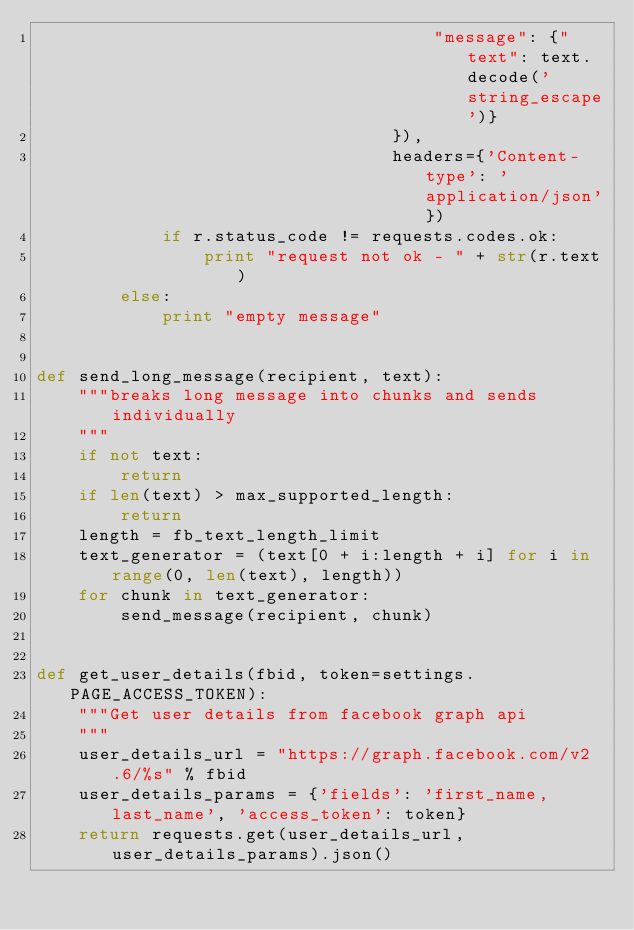<code> <loc_0><loc_0><loc_500><loc_500><_Python_>                                      "message": {"text": text.decode('string_escape')}
                                  }),
                                  headers={'Content-type': 'application/json'})
            if r.status_code != requests.codes.ok:
                print "request not ok - " + str(r.text)
        else:
            print "empty message"


def send_long_message(recipient, text):
    """breaks long message into chunks and sends individually
    """
    if not text:
        return
    if len(text) > max_supported_length:
        return
    length = fb_text_length_limit
    text_generator = (text[0 + i:length + i] for i in range(0, len(text), length))
    for chunk in text_generator:
        send_message(recipient, chunk)


def get_user_details(fbid, token=settings.PAGE_ACCESS_TOKEN):
    """Get user details from facebook graph api
    """
    user_details_url = "https://graph.facebook.com/v2.6/%s" % fbid
    user_details_params = {'fields': 'first_name, last_name', 'access_token': token}
    return requests.get(user_details_url, user_details_params).json()
</code> 